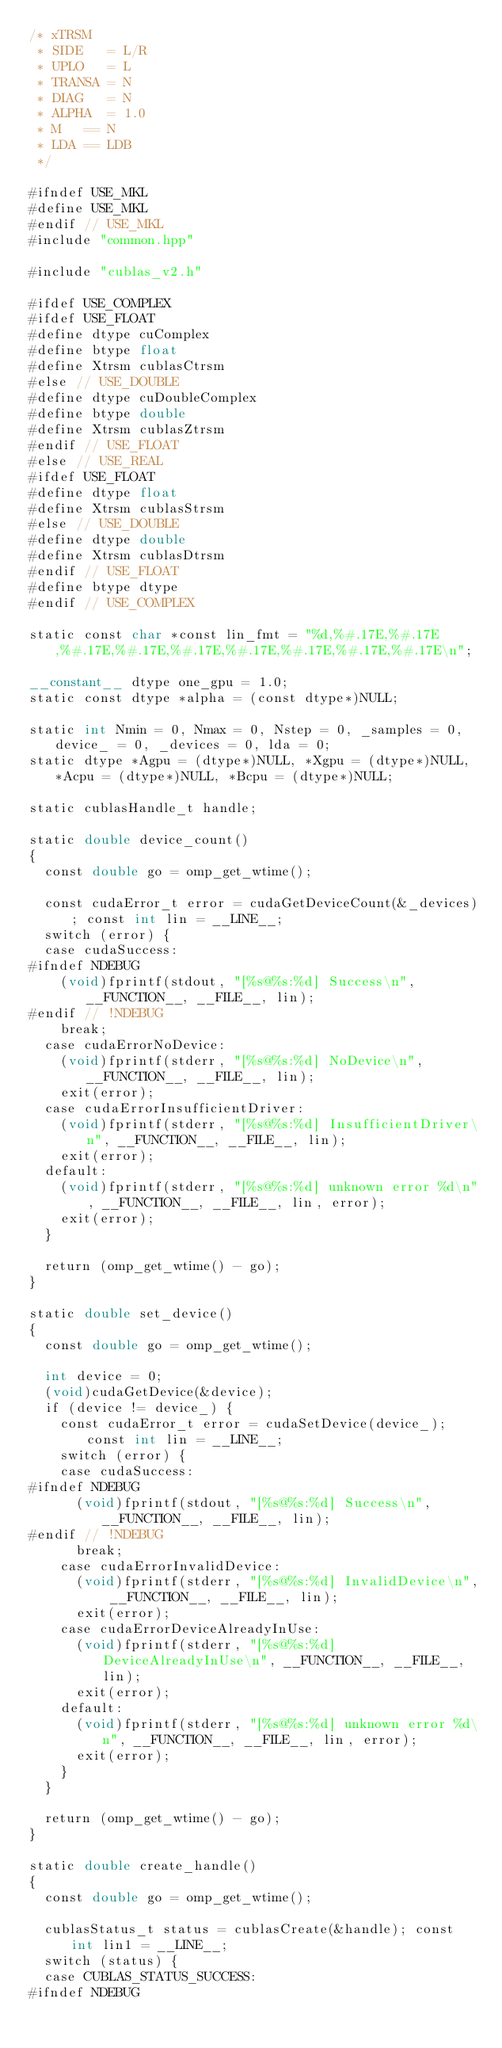Convert code to text. <code><loc_0><loc_0><loc_500><loc_500><_Cuda_>/* xTRSM
 * SIDE   = L/R
 * UPLO   = L
 * TRANSA = N
 * DIAG   = N
 * ALPHA  = 1.0
 * M   == N
 * LDA == LDB
 */

#ifndef USE_MKL
#define USE_MKL
#endif // USE_MKL
#include "common.hpp"

#include "cublas_v2.h"

#ifdef USE_COMPLEX
#ifdef USE_FLOAT
#define dtype cuComplex
#define btype float
#define Xtrsm cublasCtrsm
#else // USE_DOUBLE
#define dtype cuDoubleComplex
#define btype double
#define Xtrsm cublasZtrsm
#endif // USE_FLOAT
#else // USE_REAL
#ifdef USE_FLOAT
#define dtype float
#define Xtrsm cublasStrsm
#else // USE_DOUBLE
#define dtype double
#define Xtrsm cublasDtrsm
#endif // USE_FLOAT
#define btype dtype
#endif // USE_COMPLEX

static const char *const lin_fmt = "%d,%#.17E,%#.17E,%#.17E,%#.17E,%#.17E,%#.17E,%#.17E,%#.17E,%#.17E\n";

__constant__ dtype one_gpu = 1.0;
static const dtype *alpha = (const dtype*)NULL;

static int Nmin = 0, Nmax = 0, Nstep = 0, _samples = 0, device_ = 0, _devices = 0, lda = 0;
static dtype *Agpu = (dtype*)NULL, *Xgpu = (dtype*)NULL, *Acpu = (dtype*)NULL, *Bcpu = (dtype*)NULL;

static cublasHandle_t handle;

static double device_count()
{
  const double go = omp_get_wtime();

  const cudaError_t error = cudaGetDeviceCount(&_devices); const int lin = __LINE__;
  switch (error) {
  case cudaSuccess:
#ifndef NDEBUG
    (void)fprintf(stdout, "[%s@%s:%d] Success\n", __FUNCTION__, __FILE__, lin);
#endif // !NDEBUG
    break;
  case cudaErrorNoDevice:
    (void)fprintf(stderr, "[%s@%s:%d] NoDevice\n", __FUNCTION__, __FILE__, lin);
    exit(error);
  case cudaErrorInsufficientDriver:
    (void)fprintf(stderr, "[%s@%s:%d] InsufficientDriver\n", __FUNCTION__, __FILE__, lin);
    exit(error);
  default:
    (void)fprintf(stderr, "[%s@%s:%d] unknown error %d\n", __FUNCTION__, __FILE__, lin, error);
    exit(error);
  }

  return (omp_get_wtime() - go);
}

static double set_device()
{
  const double go = omp_get_wtime();

  int device = 0;
  (void)cudaGetDevice(&device);
  if (device != device_) {
    const cudaError_t error = cudaSetDevice(device_); const int lin = __LINE__;
    switch (error) {
    case cudaSuccess:
#ifndef NDEBUG
      (void)fprintf(stdout, "[%s@%s:%d] Success\n", __FUNCTION__, __FILE__, lin);
#endif // !NDEBUG
      break;
    case cudaErrorInvalidDevice:
      (void)fprintf(stderr, "[%s@%s:%d] InvalidDevice\n", __FUNCTION__, __FILE__, lin);
      exit(error);
    case cudaErrorDeviceAlreadyInUse:
      (void)fprintf(stderr, "[%s@%s:%d] DeviceAlreadyInUse\n", __FUNCTION__, __FILE__, lin);
      exit(error);
    default:
      (void)fprintf(stderr, "[%s@%s:%d] unknown error %d\n", __FUNCTION__, __FILE__, lin, error);
      exit(error);
    }
  }

  return (omp_get_wtime() - go);
}

static double create_handle()
{
  const double go = omp_get_wtime();

  cublasStatus_t status = cublasCreate(&handle); const int lin1 = __LINE__;
  switch (status) {
  case CUBLAS_STATUS_SUCCESS:
#ifndef NDEBUG</code> 